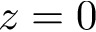<formula> <loc_0><loc_0><loc_500><loc_500>z = 0</formula> 